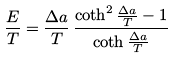<formula> <loc_0><loc_0><loc_500><loc_500>\frac { E } { T } = \frac { \Delta a } { T } \, \frac { \coth ^ { 2 } \frac { \Delta a } { T } - 1 } { \coth \frac { \Delta a } { T } }</formula> 